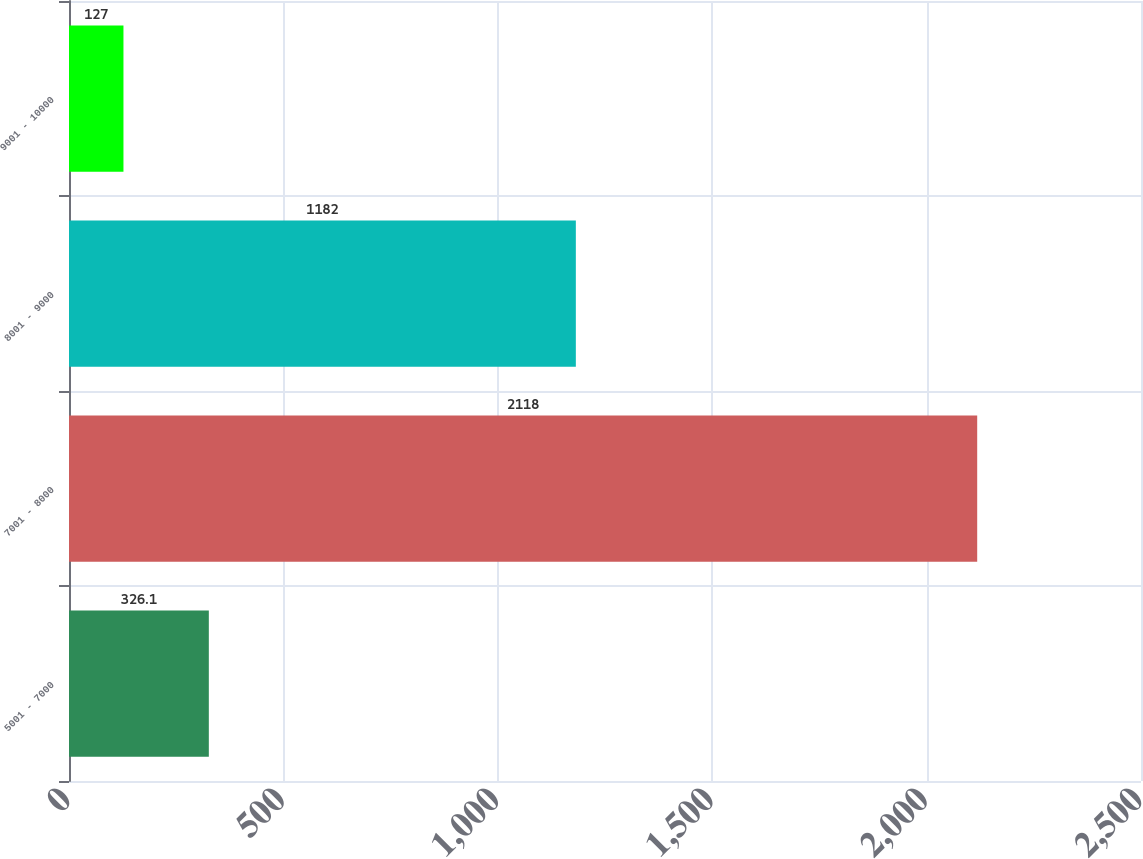<chart> <loc_0><loc_0><loc_500><loc_500><bar_chart><fcel>5001 - 7000<fcel>7001 - 8000<fcel>8001 - 9000<fcel>9001 - 10000<nl><fcel>326.1<fcel>2118<fcel>1182<fcel>127<nl></chart> 